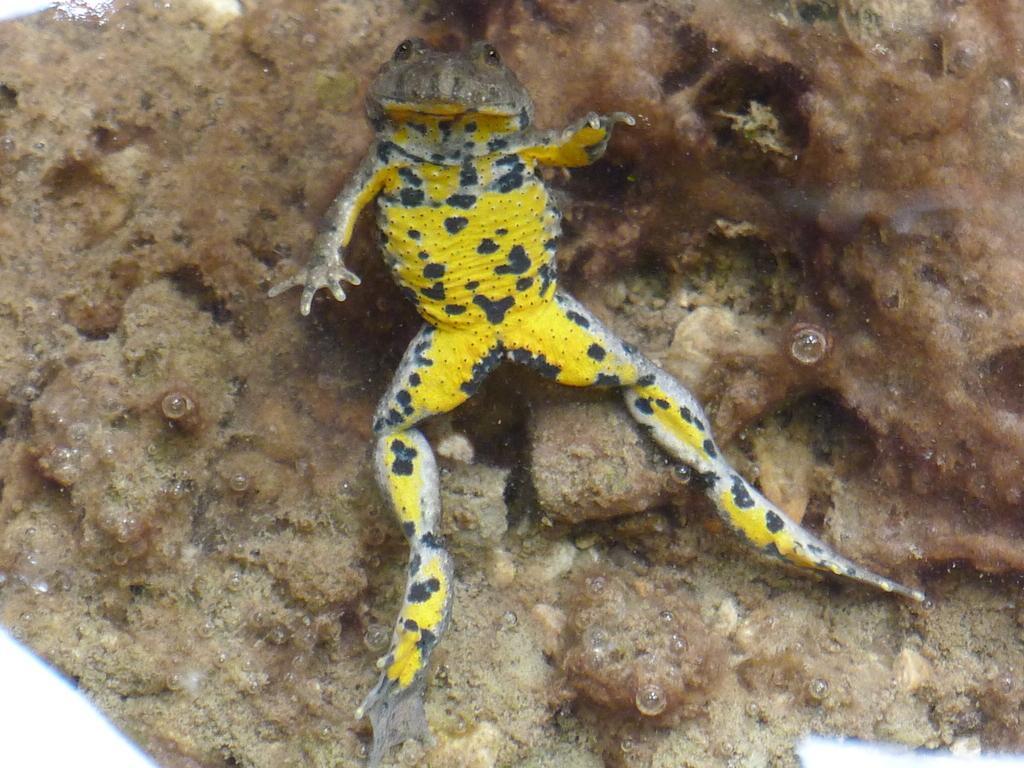How would you summarize this image in a sentence or two? In this picture I can observe frog in the middle of the picture. This frog is in yellow and black color. In the background I can observe land. 